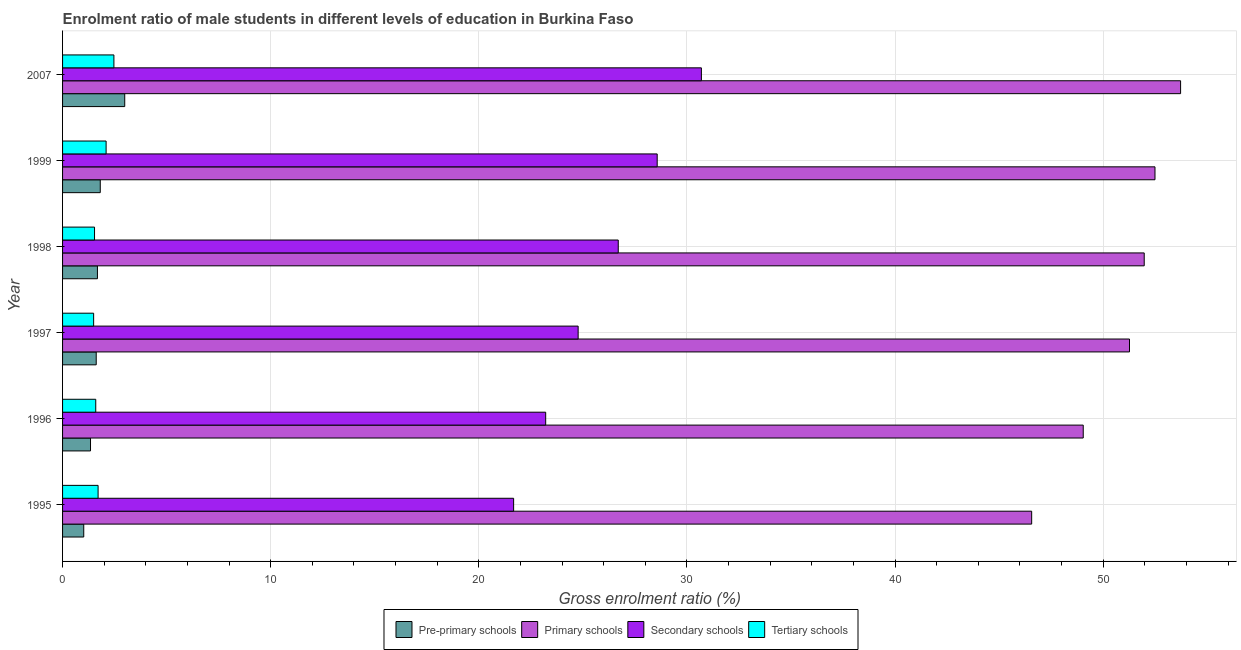Are the number of bars on each tick of the Y-axis equal?
Your answer should be very brief. Yes. How many bars are there on the 2nd tick from the top?
Provide a short and direct response. 4. In how many cases, is the number of bars for a given year not equal to the number of legend labels?
Offer a very short reply. 0. What is the gross enrolment ratio(female) in pre-primary schools in 1999?
Ensure brevity in your answer.  1.81. Across all years, what is the maximum gross enrolment ratio(female) in primary schools?
Offer a terse response. 53.72. Across all years, what is the minimum gross enrolment ratio(female) in pre-primary schools?
Provide a short and direct response. 1.02. What is the total gross enrolment ratio(female) in pre-primary schools in the graph?
Keep it short and to the point. 10.45. What is the difference between the gross enrolment ratio(female) in primary schools in 1998 and that in 1999?
Your answer should be compact. -0.52. What is the difference between the gross enrolment ratio(female) in pre-primary schools in 1997 and the gross enrolment ratio(female) in secondary schools in 1999?
Provide a succinct answer. -26.96. What is the average gross enrolment ratio(female) in secondary schools per year?
Your answer should be compact. 25.94. In the year 1995, what is the difference between the gross enrolment ratio(female) in secondary schools and gross enrolment ratio(female) in tertiary schools?
Provide a short and direct response. 19.97. In how many years, is the gross enrolment ratio(female) in pre-primary schools greater than 36 %?
Keep it short and to the point. 0. What is the ratio of the gross enrolment ratio(female) in secondary schools in 1995 to that in 2007?
Offer a very short reply. 0.71. Is the difference between the gross enrolment ratio(female) in primary schools in 1996 and 2007 greater than the difference between the gross enrolment ratio(female) in secondary schools in 1996 and 2007?
Your response must be concise. Yes. What is the difference between the highest and the second highest gross enrolment ratio(female) in tertiary schools?
Offer a very short reply. 0.37. What is the difference between the highest and the lowest gross enrolment ratio(female) in primary schools?
Provide a short and direct response. 7.16. Is the sum of the gross enrolment ratio(female) in secondary schools in 1996 and 1999 greater than the maximum gross enrolment ratio(female) in primary schools across all years?
Give a very brief answer. No. What does the 2nd bar from the top in 1995 represents?
Offer a very short reply. Secondary schools. What does the 2nd bar from the bottom in 1999 represents?
Make the answer very short. Primary schools. Is it the case that in every year, the sum of the gross enrolment ratio(female) in pre-primary schools and gross enrolment ratio(female) in primary schools is greater than the gross enrolment ratio(female) in secondary schools?
Your response must be concise. Yes. How many bars are there?
Make the answer very short. 24. Does the graph contain grids?
Make the answer very short. Yes. Where does the legend appear in the graph?
Give a very brief answer. Bottom center. What is the title of the graph?
Offer a very short reply. Enrolment ratio of male students in different levels of education in Burkina Faso. What is the Gross enrolment ratio (%) in Pre-primary schools in 1995?
Give a very brief answer. 1.02. What is the Gross enrolment ratio (%) in Primary schools in 1995?
Offer a terse response. 46.57. What is the Gross enrolment ratio (%) of Secondary schools in 1995?
Offer a terse response. 21.67. What is the Gross enrolment ratio (%) of Tertiary schools in 1995?
Give a very brief answer. 1.71. What is the Gross enrolment ratio (%) in Pre-primary schools in 1996?
Make the answer very short. 1.34. What is the Gross enrolment ratio (%) in Primary schools in 1996?
Keep it short and to the point. 49.04. What is the Gross enrolment ratio (%) of Secondary schools in 1996?
Provide a succinct answer. 23.21. What is the Gross enrolment ratio (%) in Tertiary schools in 1996?
Your answer should be compact. 1.59. What is the Gross enrolment ratio (%) of Pre-primary schools in 1997?
Keep it short and to the point. 1.62. What is the Gross enrolment ratio (%) in Primary schools in 1997?
Provide a short and direct response. 51.27. What is the Gross enrolment ratio (%) in Secondary schools in 1997?
Your response must be concise. 24.77. What is the Gross enrolment ratio (%) of Tertiary schools in 1997?
Your response must be concise. 1.49. What is the Gross enrolment ratio (%) in Pre-primary schools in 1998?
Offer a terse response. 1.68. What is the Gross enrolment ratio (%) of Primary schools in 1998?
Your answer should be compact. 51.97. What is the Gross enrolment ratio (%) of Secondary schools in 1998?
Make the answer very short. 26.7. What is the Gross enrolment ratio (%) of Tertiary schools in 1998?
Your answer should be very brief. 1.54. What is the Gross enrolment ratio (%) in Pre-primary schools in 1999?
Keep it short and to the point. 1.81. What is the Gross enrolment ratio (%) of Primary schools in 1999?
Your answer should be compact. 52.49. What is the Gross enrolment ratio (%) in Secondary schools in 1999?
Your answer should be very brief. 28.57. What is the Gross enrolment ratio (%) in Tertiary schools in 1999?
Make the answer very short. 2.09. What is the Gross enrolment ratio (%) of Pre-primary schools in 2007?
Make the answer very short. 2.99. What is the Gross enrolment ratio (%) in Primary schools in 2007?
Your answer should be very brief. 53.72. What is the Gross enrolment ratio (%) in Secondary schools in 2007?
Make the answer very short. 30.7. What is the Gross enrolment ratio (%) of Tertiary schools in 2007?
Keep it short and to the point. 2.47. Across all years, what is the maximum Gross enrolment ratio (%) in Pre-primary schools?
Your answer should be compact. 2.99. Across all years, what is the maximum Gross enrolment ratio (%) in Primary schools?
Provide a short and direct response. 53.72. Across all years, what is the maximum Gross enrolment ratio (%) of Secondary schools?
Make the answer very short. 30.7. Across all years, what is the maximum Gross enrolment ratio (%) of Tertiary schools?
Provide a short and direct response. 2.47. Across all years, what is the minimum Gross enrolment ratio (%) in Pre-primary schools?
Provide a short and direct response. 1.02. Across all years, what is the minimum Gross enrolment ratio (%) in Primary schools?
Your answer should be compact. 46.57. Across all years, what is the minimum Gross enrolment ratio (%) in Secondary schools?
Give a very brief answer. 21.67. Across all years, what is the minimum Gross enrolment ratio (%) of Tertiary schools?
Make the answer very short. 1.49. What is the total Gross enrolment ratio (%) in Pre-primary schools in the graph?
Offer a terse response. 10.45. What is the total Gross enrolment ratio (%) in Primary schools in the graph?
Ensure brevity in your answer.  305.06. What is the total Gross enrolment ratio (%) in Secondary schools in the graph?
Provide a short and direct response. 155.63. What is the total Gross enrolment ratio (%) in Tertiary schools in the graph?
Provide a succinct answer. 10.89. What is the difference between the Gross enrolment ratio (%) of Pre-primary schools in 1995 and that in 1996?
Your answer should be compact. -0.33. What is the difference between the Gross enrolment ratio (%) of Primary schools in 1995 and that in 1996?
Your response must be concise. -2.48. What is the difference between the Gross enrolment ratio (%) of Secondary schools in 1995 and that in 1996?
Give a very brief answer. -1.54. What is the difference between the Gross enrolment ratio (%) of Tertiary schools in 1995 and that in 1996?
Your answer should be compact. 0.11. What is the difference between the Gross enrolment ratio (%) of Pre-primary schools in 1995 and that in 1997?
Your answer should be compact. -0.6. What is the difference between the Gross enrolment ratio (%) of Primary schools in 1995 and that in 1997?
Offer a very short reply. -4.7. What is the difference between the Gross enrolment ratio (%) of Secondary schools in 1995 and that in 1997?
Provide a short and direct response. -3.1. What is the difference between the Gross enrolment ratio (%) in Tertiary schools in 1995 and that in 1997?
Offer a terse response. 0.21. What is the difference between the Gross enrolment ratio (%) of Pre-primary schools in 1995 and that in 1998?
Ensure brevity in your answer.  -0.66. What is the difference between the Gross enrolment ratio (%) in Primary schools in 1995 and that in 1998?
Offer a very short reply. -5.41. What is the difference between the Gross enrolment ratio (%) in Secondary schools in 1995 and that in 1998?
Provide a succinct answer. -5.03. What is the difference between the Gross enrolment ratio (%) in Tertiary schools in 1995 and that in 1998?
Give a very brief answer. 0.17. What is the difference between the Gross enrolment ratio (%) in Pre-primary schools in 1995 and that in 1999?
Provide a succinct answer. -0.79. What is the difference between the Gross enrolment ratio (%) in Primary schools in 1995 and that in 1999?
Give a very brief answer. -5.93. What is the difference between the Gross enrolment ratio (%) in Secondary schools in 1995 and that in 1999?
Your response must be concise. -6.9. What is the difference between the Gross enrolment ratio (%) of Tertiary schools in 1995 and that in 1999?
Provide a succinct answer. -0.39. What is the difference between the Gross enrolment ratio (%) of Pre-primary schools in 1995 and that in 2007?
Offer a terse response. -1.97. What is the difference between the Gross enrolment ratio (%) of Primary schools in 1995 and that in 2007?
Offer a very short reply. -7.16. What is the difference between the Gross enrolment ratio (%) of Secondary schools in 1995 and that in 2007?
Make the answer very short. -9.02. What is the difference between the Gross enrolment ratio (%) in Tertiary schools in 1995 and that in 2007?
Make the answer very short. -0.76. What is the difference between the Gross enrolment ratio (%) in Pre-primary schools in 1996 and that in 1997?
Give a very brief answer. -0.27. What is the difference between the Gross enrolment ratio (%) of Primary schools in 1996 and that in 1997?
Offer a very short reply. -2.22. What is the difference between the Gross enrolment ratio (%) in Secondary schools in 1996 and that in 1997?
Make the answer very short. -1.56. What is the difference between the Gross enrolment ratio (%) in Tertiary schools in 1996 and that in 1997?
Make the answer very short. 0.1. What is the difference between the Gross enrolment ratio (%) of Pre-primary schools in 1996 and that in 1998?
Offer a very short reply. -0.33. What is the difference between the Gross enrolment ratio (%) of Primary schools in 1996 and that in 1998?
Your answer should be very brief. -2.93. What is the difference between the Gross enrolment ratio (%) of Secondary schools in 1996 and that in 1998?
Keep it short and to the point. -3.49. What is the difference between the Gross enrolment ratio (%) in Tertiary schools in 1996 and that in 1998?
Offer a very short reply. 0.06. What is the difference between the Gross enrolment ratio (%) in Pre-primary schools in 1996 and that in 1999?
Keep it short and to the point. -0.47. What is the difference between the Gross enrolment ratio (%) in Primary schools in 1996 and that in 1999?
Your answer should be compact. -3.45. What is the difference between the Gross enrolment ratio (%) of Secondary schools in 1996 and that in 1999?
Offer a terse response. -5.36. What is the difference between the Gross enrolment ratio (%) in Tertiary schools in 1996 and that in 1999?
Provide a succinct answer. -0.5. What is the difference between the Gross enrolment ratio (%) of Pre-primary schools in 1996 and that in 2007?
Give a very brief answer. -1.64. What is the difference between the Gross enrolment ratio (%) in Primary schools in 1996 and that in 2007?
Your answer should be compact. -4.68. What is the difference between the Gross enrolment ratio (%) in Secondary schools in 1996 and that in 2007?
Provide a short and direct response. -7.48. What is the difference between the Gross enrolment ratio (%) in Tertiary schools in 1996 and that in 2007?
Keep it short and to the point. -0.87. What is the difference between the Gross enrolment ratio (%) in Pre-primary schools in 1997 and that in 1998?
Provide a short and direct response. -0.06. What is the difference between the Gross enrolment ratio (%) in Primary schools in 1997 and that in 1998?
Your response must be concise. -0.71. What is the difference between the Gross enrolment ratio (%) in Secondary schools in 1997 and that in 1998?
Provide a short and direct response. -1.93. What is the difference between the Gross enrolment ratio (%) of Tertiary schools in 1997 and that in 1998?
Your answer should be very brief. -0.04. What is the difference between the Gross enrolment ratio (%) in Pre-primary schools in 1997 and that in 1999?
Your response must be concise. -0.19. What is the difference between the Gross enrolment ratio (%) of Primary schools in 1997 and that in 1999?
Ensure brevity in your answer.  -1.22. What is the difference between the Gross enrolment ratio (%) in Secondary schools in 1997 and that in 1999?
Make the answer very short. -3.8. What is the difference between the Gross enrolment ratio (%) in Tertiary schools in 1997 and that in 1999?
Provide a succinct answer. -0.6. What is the difference between the Gross enrolment ratio (%) in Pre-primary schools in 1997 and that in 2007?
Offer a very short reply. -1.37. What is the difference between the Gross enrolment ratio (%) of Primary schools in 1997 and that in 2007?
Offer a very short reply. -2.45. What is the difference between the Gross enrolment ratio (%) of Secondary schools in 1997 and that in 2007?
Your answer should be very brief. -5.92. What is the difference between the Gross enrolment ratio (%) in Tertiary schools in 1997 and that in 2007?
Your response must be concise. -0.97. What is the difference between the Gross enrolment ratio (%) of Pre-primary schools in 1998 and that in 1999?
Keep it short and to the point. -0.14. What is the difference between the Gross enrolment ratio (%) in Primary schools in 1998 and that in 1999?
Your answer should be very brief. -0.52. What is the difference between the Gross enrolment ratio (%) of Secondary schools in 1998 and that in 1999?
Keep it short and to the point. -1.87. What is the difference between the Gross enrolment ratio (%) in Tertiary schools in 1998 and that in 1999?
Keep it short and to the point. -0.56. What is the difference between the Gross enrolment ratio (%) in Pre-primary schools in 1998 and that in 2007?
Provide a succinct answer. -1.31. What is the difference between the Gross enrolment ratio (%) of Primary schools in 1998 and that in 2007?
Offer a very short reply. -1.75. What is the difference between the Gross enrolment ratio (%) in Secondary schools in 1998 and that in 2007?
Ensure brevity in your answer.  -4. What is the difference between the Gross enrolment ratio (%) in Tertiary schools in 1998 and that in 2007?
Give a very brief answer. -0.93. What is the difference between the Gross enrolment ratio (%) of Pre-primary schools in 1999 and that in 2007?
Provide a short and direct response. -1.18. What is the difference between the Gross enrolment ratio (%) of Primary schools in 1999 and that in 2007?
Make the answer very short. -1.23. What is the difference between the Gross enrolment ratio (%) in Secondary schools in 1999 and that in 2007?
Provide a short and direct response. -2.12. What is the difference between the Gross enrolment ratio (%) in Tertiary schools in 1999 and that in 2007?
Make the answer very short. -0.37. What is the difference between the Gross enrolment ratio (%) in Pre-primary schools in 1995 and the Gross enrolment ratio (%) in Primary schools in 1996?
Your response must be concise. -48.03. What is the difference between the Gross enrolment ratio (%) in Pre-primary schools in 1995 and the Gross enrolment ratio (%) in Secondary schools in 1996?
Provide a succinct answer. -22.2. What is the difference between the Gross enrolment ratio (%) in Pre-primary schools in 1995 and the Gross enrolment ratio (%) in Tertiary schools in 1996?
Your answer should be compact. -0.58. What is the difference between the Gross enrolment ratio (%) in Primary schools in 1995 and the Gross enrolment ratio (%) in Secondary schools in 1996?
Provide a succinct answer. 23.35. What is the difference between the Gross enrolment ratio (%) of Primary schools in 1995 and the Gross enrolment ratio (%) of Tertiary schools in 1996?
Make the answer very short. 44.97. What is the difference between the Gross enrolment ratio (%) of Secondary schools in 1995 and the Gross enrolment ratio (%) of Tertiary schools in 1996?
Offer a terse response. 20.08. What is the difference between the Gross enrolment ratio (%) of Pre-primary schools in 1995 and the Gross enrolment ratio (%) of Primary schools in 1997?
Provide a succinct answer. -50.25. What is the difference between the Gross enrolment ratio (%) of Pre-primary schools in 1995 and the Gross enrolment ratio (%) of Secondary schools in 1997?
Your response must be concise. -23.76. What is the difference between the Gross enrolment ratio (%) in Pre-primary schools in 1995 and the Gross enrolment ratio (%) in Tertiary schools in 1997?
Make the answer very short. -0.47. What is the difference between the Gross enrolment ratio (%) in Primary schools in 1995 and the Gross enrolment ratio (%) in Secondary schools in 1997?
Your response must be concise. 21.79. What is the difference between the Gross enrolment ratio (%) of Primary schools in 1995 and the Gross enrolment ratio (%) of Tertiary schools in 1997?
Provide a succinct answer. 45.07. What is the difference between the Gross enrolment ratio (%) in Secondary schools in 1995 and the Gross enrolment ratio (%) in Tertiary schools in 1997?
Your answer should be very brief. 20.18. What is the difference between the Gross enrolment ratio (%) of Pre-primary schools in 1995 and the Gross enrolment ratio (%) of Primary schools in 1998?
Offer a very short reply. -50.96. What is the difference between the Gross enrolment ratio (%) of Pre-primary schools in 1995 and the Gross enrolment ratio (%) of Secondary schools in 1998?
Keep it short and to the point. -25.68. What is the difference between the Gross enrolment ratio (%) of Pre-primary schools in 1995 and the Gross enrolment ratio (%) of Tertiary schools in 1998?
Your answer should be very brief. -0.52. What is the difference between the Gross enrolment ratio (%) in Primary schools in 1995 and the Gross enrolment ratio (%) in Secondary schools in 1998?
Your answer should be very brief. 19.87. What is the difference between the Gross enrolment ratio (%) of Primary schools in 1995 and the Gross enrolment ratio (%) of Tertiary schools in 1998?
Provide a short and direct response. 45.03. What is the difference between the Gross enrolment ratio (%) of Secondary schools in 1995 and the Gross enrolment ratio (%) of Tertiary schools in 1998?
Make the answer very short. 20.14. What is the difference between the Gross enrolment ratio (%) in Pre-primary schools in 1995 and the Gross enrolment ratio (%) in Primary schools in 1999?
Give a very brief answer. -51.47. What is the difference between the Gross enrolment ratio (%) of Pre-primary schools in 1995 and the Gross enrolment ratio (%) of Secondary schools in 1999?
Give a very brief answer. -27.55. What is the difference between the Gross enrolment ratio (%) in Pre-primary schools in 1995 and the Gross enrolment ratio (%) in Tertiary schools in 1999?
Provide a succinct answer. -1.07. What is the difference between the Gross enrolment ratio (%) in Primary schools in 1995 and the Gross enrolment ratio (%) in Secondary schools in 1999?
Keep it short and to the point. 17.99. What is the difference between the Gross enrolment ratio (%) in Primary schools in 1995 and the Gross enrolment ratio (%) in Tertiary schools in 1999?
Keep it short and to the point. 44.47. What is the difference between the Gross enrolment ratio (%) in Secondary schools in 1995 and the Gross enrolment ratio (%) in Tertiary schools in 1999?
Keep it short and to the point. 19.58. What is the difference between the Gross enrolment ratio (%) of Pre-primary schools in 1995 and the Gross enrolment ratio (%) of Primary schools in 2007?
Keep it short and to the point. -52.7. What is the difference between the Gross enrolment ratio (%) of Pre-primary schools in 1995 and the Gross enrolment ratio (%) of Secondary schools in 2007?
Your answer should be compact. -29.68. What is the difference between the Gross enrolment ratio (%) of Pre-primary schools in 1995 and the Gross enrolment ratio (%) of Tertiary schools in 2007?
Ensure brevity in your answer.  -1.45. What is the difference between the Gross enrolment ratio (%) of Primary schools in 1995 and the Gross enrolment ratio (%) of Secondary schools in 2007?
Make the answer very short. 15.87. What is the difference between the Gross enrolment ratio (%) in Primary schools in 1995 and the Gross enrolment ratio (%) in Tertiary schools in 2007?
Your answer should be compact. 44.1. What is the difference between the Gross enrolment ratio (%) in Secondary schools in 1995 and the Gross enrolment ratio (%) in Tertiary schools in 2007?
Offer a terse response. 19.21. What is the difference between the Gross enrolment ratio (%) in Pre-primary schools in 1996 and the Gross enrolment ratio (%) in Primary schools in 1997?
Provide a short and direct response. -49.92. What is the difference between the Gross enrolment ratio (%) of Pre-primary schools in 1996 and the Gross enrolment ratio (%) of Secondary schools in 1997?
Ensure brevity in your answer.  -23.43. What is the difference between the Gross enrolment ratio (%) of Pre-primary schools in 1996 and the Gross enrolment ratio (%) of Tertiary schools in 1997?
Your answer should be very brief. -0.15. What is the difference between the Gross enrolment ratio (%) of Primary schools in 1996 and the Gross enrolment ratio (%) of Secondary schools in 1997?
Provide a short and direct response. 24.27. What is the difference between the Gross enrolment ratio (%) in Primary schools in 1996 and the Gross enrolment ratio (%) in Tertiary schools in 1997?
Your response must be concise. 47.55. What is the difference between the Gross enrolment ratio (%) in Secondary schools in 1996 and the Gross enrolment ratio (%) in Tertiary schools in 1997?
Give a very brief answer. 21.72. What is the difference between the Gross enrolment ratio (%) of Pre-primary schools in 1996 and the Gross enrolment ratio (%) of Primary schools in 1998?
Make the answer very short. -50.63. What is the difference between the Gross enrolment ratio (%) in Pre-primary schools in 1996 and the Gross enrolment ratio (%) in Secondary schools in 1998?
Ensure brevity in your answer.  -25.36. What is the difference between the Gross enrolment ratio (%) in Pre-primary schools in 1996 and the Gross enrolment ratio (%) in Tertiary schools in 1998?
Your response must be concise. -0.19. What is the difference between the Gross enrolment ratio (%) of Primary schools in 1996 and the Gross enrolment ratio (%) of Secondary schools in 1998?
Give a very brief answer. 22.34. What is the difference between the Gross enrolment ratio (%) of Primary schools in 1996 and the Gross enrolment ratio (%) of Tertiary schools in 1998?
Provide a short and direct response. 47.51. What is the difference between the Gross enrolment ratio (%) of Secondary schools in 1996 and the Gross enrolment ratio (%) of Tertiary schools in 1998?
Your response must be concise. 21.68. What is the difference between the Gross enrolment ratio (%) of Pre-primary schools in 1996 and the Gross enrolment ratio (%) of Primary schools in 1999?
Keep it short and to the point. -51.15. What is the difference between the Gross enrolment ratio (%) of Pre-primary schools in 1996 and the Gross enrolment ratio (%) of Secondary schools in 1999?
Your response must be concise. -27.23. What is the difference between the Gross enrolment ratio (%) in Pre-primary schools in 1996 and the Gross enrolment ratio (%) in Tertiary schools in 1999?
Make the answer very short. -0.75. What is the difference between the Gross enrolment ratio (%) in Primary schools in 1996 and the Gross enrolment ratio (%) in Secondary schools in 1999?
Your response must be concise. 20.47. What is the difference between the Gross enrolment ratio (%) of Primary schools in 1996 and the Gross enrolment ratio (%) of Tertiary schools in 1999?
Make the answer very short. 46.95. What is the difference between the Gross enrolment ratio (%) of Secondary schools in 1996 and the Gross enrolment ratio (%) of Tertiary schools in 1999?
Give a very brief answer. 21.12. What is the difference between the Gross enrolment ratio (%) of Pre-primary schools in 1996 and the Gross enrolment ratio (%) of Primary schools in 2007?
Ensure brevity in your answer.  -52.38. What is the difference between the Gross enrolment ratio (%) of Pre-primary schools in 1996 and the Gross enrolment ratio (%) of Secondary schools in 2007?
Your answer should be compact. -29.35. What is the difference between the Gross enrolment ratio (%) of Pre-primary schools in 1996 and the Gross enrolment ratio (%) of Tertiary schools in 2007?
Offer a terse response. -1.12. What is the difference between the Gross enrolment ratio (%) of Primary schools in 1996 and the Gross enrolment ratio (%) of Secondary schools in 2007?
Offer a terse response. 18.35. What is the difference between the Gross enrolment ratio (%) of Primary schools in 1996 and the Gross enrolment ratio (%) of Tertiary schools in 2007?
Your answer should be very brief. 46.58. What is the difference between the Gross enrolment ratio (%) in Secondary schools in 1996 and the Gross enrolment ratio (%) in Tertiary schools in 2007?
Give a very brief answer. 20.75. What is the difference between the Gross enrolment ratio (%) of Pre-primary schools in 1997 and the Gross enrolment ratio (%) of Primary schools in 1998?
Provide a short and direct response. -50.36. What is the difference between the Gross enrolment ratio (%) of Pre-primary schools in 1997 and the Gross enrolment ratio (%) of Secondary schools in 1998?
Your response must be concise. -25.08. What is the difference between the Gross enrolment ratio (%) of Pre-primary schools in 1997 and the Gross enrolment ratio (%) of Tertiary schools in 1998?
Your answer should be compact. 0.08. What is the difference between the Gross enrolment ratio (%) of Primary schools in 1997 and the Gross enrolment ratio (%) of Secondary schools in 1998?
Your answer should be compact. 24.57. What is the difference between the Gross enrolment ratio (%) in Primary schools in 1997 and the Gross enrolment ratio (%) in Tertiary schools in 1998?
Offer a terse response. 49.73. What is the difference between the Gross enrolment ratio (%) in Secondary schools in 1997 and the Gross enrolment ratio (%) in Tertiary schools in 1998?
Make the answer very short. 23.24. What is the difference between the Gross enrolment ratio (%) in Pre-primary schools in 1997 and the Gross enrolment ratio (%) in Primary schools in 1999?
Keep it short and to the point. -50.87. What is the difference between the Gross enrolment ratio (%) in Pre-primary schools in 1997 and the Gross enrolment ratio (%) in Secondary schools in 1999?
Provide a succinct answer. -26.96. What is the difference between the Gross enrolment ratio (%) in Pre-primary schools in 1997 and the Gross enrolment ratio (%) in Tertiary schools in 1999?
Your response must be concise. -0.48. What is the difference between the Gross enrolment ratio (%) of Primary schools in 1997 and the Gross enrolment ratio (%) of Secondary schools in 1999?
Ensure brevity in your answer.  22.69. What is the difference between the Gross enrolment ratio (%) of Primary schools in 1997 and the Gross enrolment ratio (%) of Tertiary schools in 1999?
Offer a terse response. 49.17. What is the difference between the Gross enrolment ratio (%) of Secondary schools in 1997 and the Gross enrolment ratio (%) of Tertiary schools in 1999?
Make the answer very short. 22.68. What is the difference between the Gross enrolment ratio (%) of Pre-primary schools in 1997 and the Gross enrolment ratio (%) of Primary schools in 2007?
Your answer should be very brief. -52.1. What is the difference between the Gross enrolment ratio (%) in Pre-primary schools in 1997 and the Gross enrolment ratio (%) in Secondary schools in 2007?
Your answer should be compact. -29.08. What is the difference between the Gross enrolment ratio (%) in Pre-primary schools in 1997 and the Gross enrolment ratio (%) in Tertiary schools in 2007?
Ensure brevity in your answer.  -0.85. What is the difference between the Gross enrolment ratio (%) of Primary schools in 1997 and the Gross enrolment ratio (%) of Secondary schools in 2007?
Your answer should be compact. 20.57. What is the difference between the Gross enrolment ratio (%) of Primary schools in 1997 and the Gross enrolment ratio (%) of Tertiary schools in 2007?
Ensure brevity in your answer.  48.8. What is the difference between the Gross enrolment ratio (%) of Secondary schools in 1997 and the Gross enrolment ratio (%) of Tertiary schools in 2007?
Your answer should be compact. 22.31. What is the difference between the Gross enrolment ratio (%) of Pre-primary schools in 1998 and the Gross enrolment ratio (%) of Primary schools in 1999?
Provide a succinct answer. -50.82. What is the difference between the Gross enrolment ratio (%) of Pre-primary schools in 1998 and the Gross enrolment ratio (%) of Secondary schools in 1999?
Offer a terse response. -26.9. What is the difference between the Gross enrolment ratio (%) in Pre-primary schools in 1998 and the Gross enrolment ratio (%) in Tertiary schools in 1999?
Your answer should be very brief. -0.42. What is the difference between the Gross enrolment ratio (%) in Primary schools in 1998 and the Gross enrolment ratio (%) in Secondary schools in 1999?
Keep it short and to the point. 23.4. What is the difference between the Gross enrolment ratio (%) of Primary schools in 1998 and the Gross enrolment ratio (%) of Tertiary schools in 1999?
Provide a succinct answer. 49.88. What is the difference between the Gross enrolment ratio (%) in Secondary schools in 1998 and the Gross enrolment ratio (%) in Tertiary schools in 1999?
Keep it short and to the point. 24.61. What is the difference between the Gross enrolment ratio (%) of Pre-primary schools in 1998 and the Gross enrolment ratio (%) of Primary schools in 2007?
Make the answer very short. -52.05. What is the difference between the Gross enrolment ratio (%) in Pre-primary schools in 1998 and the Gross enrolment ratio (%) in Secondary schools in 2007?
Ensure brevity in your answer.  -29.02. What is the difference between the Gross enrolment ratio (%) of Pre-primary schools in 1998 and the Gross enrolment ratio (%) of Tertiary schools in 2007?
Provide a short and direct response. -0.79. What is the difference between the Gross enrolment ratio (%) in Primary schools in 1998 and the Gross enrolment ratio (%) in Secondary schools in 2007?
Give a very brief answer. 21.28. What is the difference between the Gross enrolment ratio (%) in Primary schools in 1998 and the Gross enrolment ratio (%) in Tertiary schools in 2007?
Offer a terse response. 49.51. What is the difference between the Gross enrolment ratio (%) of Secondary schools in 1998 and the Gross enrolment ratio (%) of Tertiary schools in 2007?
Keep it short and to the point. 24.23. What is the difference between the Gross enrolment ratio (%) in Pre-primary schools in 1999 and the Gross enrolment ratio (%) in Primary schools in 2007?
Your answer should be compact. -51.91. What is the difference between the Gross enrolment ratio (%) of Pre-primary schools in 1999 and the Gross enrolment ratio (%) of Secondary schools in 2007?
Offer a terse response. -28.88. What is the difference between the Gross enrolment ratio (%) of Pre-primary schools in 1999 and the Gross enrolment ratio (%) of Tertiary schools in 2007?
Make the answer very short. -0.66. What is the difference between the Gross enrolment ratio (%) of Primary schools in 1999 and the Gross enrolment ratio (%) of Secondary schools in 2007?
Give a very brief answer. 21.8. What is the difference between the Gross enrolment ratio (%) in Primary schools in 1999 and the Gross enrolment ratio (%) in Tertiary schools in 2007?
Keep it short and to the point. 50.02. What is the difference between the Gross enrolment ratio (%) in Secondary schools in 1999 and the Gross enrolment ratio (%) in Tertiary schools in 2007?
Offer a very short reply. 26.11. What is the average Gross enrolment ratio (%) of Pre-primary schools per year?
Offer a terse response. 1.74. What is the average Gross enrolment ratio (%) of Primary schools per year?
Offer a very short reply. 50.84. What is the average Gross enrolment ratio (%) of Secondary schools per year?
Offer a terse response. 25.94. What is the average Gross enrolment ratio (%) of Tertiary schools per year?
Your answer should be very brief. 1.81. In the year 1995, what is the difference between the Gross enrolment ratio (%) in Pre-primary schools and Gross enrolment ratio (%) in Primary schools?
Give a very brief answer. -45.55. In the year 1995, what is the difference between the Gross enrolment ratio (%) in Pre-primary schools and Gross enrolment ratio (%) in Secondary schools?
Provide a short and direct response. -20.66. In the year 1995, what is the difference between the Gross enrolment ratio (%) of Pre-primary schools and Gross enrolment ratio (%) of Tertiary schools?
Make the answer very short. -0.69. In the year 1995, what is the difference between the Gross enrolment ratio (%) of Primary schools and Gross enrolment ratio (%) of Secondary schools?
Make the answer very short. 24.89. In the year 1995, what is the difference between the Gross enrolment ratio (%) in Primary schools and Gross enrolment ratio (%) in Tertiary schools?
Ensure brevity in your answer.  44.86. In the year 1995, what is the difference between the Gross enrolment ratio (%) of Secondary schools and Gross enrolment ratio (%) of Tertiary schools?
Your answer should be very brief. 19.97. In the year 1996, what is the difference between the Gross enrolment ratio (%) of Pre-primary schools and Gross enrolment ratio (%) of Primary schools?
Provide a short and direct response. -47.7. In the year 1996, what is the difference between the Gross enrolment ratio (%) in Pre-primary schools and Gross enrolment ratio (%) in Secondary schools?
Keep it short and to the point. -21.87. In the year 1996, what is the difference between the Gross enrolment ratio (%) in Pre-primary schools and Gross enrolment ratio (%) in Tertiary schools?
Ensure brevity in your answer.  -0.25. In the year 1996, what is the difference between the Gross enrolment ratio (%) in Primary schools and Gross enrolment ratio (%) in Secondary schools?
Make the answer very short. 25.83. In the year 1996, what is the difference between the Gross enrolment ratio (%) in Primary schools and Gross enrolment ratio (%) in Tertiary schools?
Ensure brevity in your answer.  47.45. In the year 1996, what is the difference between the Gross enrolment ratio (%) in Secondary schools and Gross enrolment ratio (%) in Tertiary schools?
Provide a short and direct response. 21.62. In the year 1997, what is the difference between the Gross enrolment ratio (%) of Pre-primary schools and Gross enrolment ratio (%) of Primary schools?
Ensure brevity in your answer.  -49.65. In the year 1997, what is the difference between the Gross enrolment ratio (%) of Pre-primary schools and Gross enrolment ratio (%) of Secondary schools?
Provide a succinct answer. -23.16. In the year 1997, what is the difference between the Gross enrolment ratio (%) in Pre-primary schools and Gross enrolment ratio (%) in Tertiary schools?
Make the answer very short. 0.12. In the year 1997, what is the difference between the Gross enrolment ratio (%) of Primary schools and Gross enrolment ratio (%) of Secondary schools?
Offer a very short reply. 26.49. In the year 1997, what is the difference between the Gross enrolment ratio (%) of Primary schools and Gross enrolment ratio (%) of Tertiary schools?
Provide a succinct answer. 49.77. In the year 1997, what is the difference between the Gross enrolment ratio (%) in Secondary schools and Gross enrolment ratio (%) in Tertiary schools?
Your answer should be very brief. 23.28. In the year 1998, what is the difference between the Gross enrolment ratio (%) in Pre-primary schools and Gross enrolment ratio (%) in Primary schools?
Your response must be concise. -50.3. In the year 1998, what is the difference between the Gross enrolment ratio (%) of Pre-primary schools and Gross enrolment ratio (%) of Secondary schools?
Your answer should be compact. -25.02. In the year 1998, what is the difference between the Gross enrolment ratio (%) in Pre-primary schools and Gross enrolment ratio (%) in Tertiary schools?
Offer a terse response. 0.14. In the year 1998, what is the difference between the Gross enrolment ratio (%) of Primary schools and Gross enrolment ratio (%) of Secondary schools?
Ensure brevity in your answer.  25.27. In the year 1998, what is the difference between the Gross enrolment ratio (%) of Primary schools and Gross enrolment ratio (%) of Tertiary schools?
Your response must be concise. 50.44. In the year 1998, what is the difference between the Gross enrolment ratio (%) of Secondary schools and Gross enrolment ratio (%) of Tertiary schools?
Give a very brief answer. 25.16. In the year 1999, what is the difference between the Gross enrolment ratio (%) of Pre-primary schools and Gross enrolment ratio (%) of Primary schools?
Ensure brevity in your answer.  -50.68. In the year 1999, what is the difference between the Gross enrolment ratio (%) of Pre-primary schools and Gross enrolment ratio (%) of Secondary schools?
Offer a terse response. -26.76. In the year 1999, what is the difference between the Gross enrolment ratio (%) of Pre-primary schools and Gross enrolment ratio (%) of Tertiary schools?
Provide a succinct answer. -0.28. In the year 1999, what is the difference between the Gross enrolment ratio (%) of Primary schools and Gross enrolment ratio (%) of Secondary schools?
Your answer should be very brief. 23.92. In the year 1999, what is the difference between the Gross enrolment ratio (%) of Primary schools and Gross enrolment ratio (%) of Tertiary schools?
Offer a very short reply. 50.4. In the year 1999, what is the difference between the Gross enrolment ratio (%) in Secondary schools and Gross enrolment ratio (%) in Tertiary schools?
Make the answer very short. 26.48. In the year 2007, what is the difference between the Gross enrolment ratio (%) in Pre-primary schools and Gross enrolment ratio (%) in Primary schools?
Give a very brief answer. -50.73. In the year 2007, what is the difference between the Gross enrolment ratio (%) of Pre-primary schools and Gross enrolment ratio (%) of Secondary schools?
Keep it short and to the point. -27.71. In the year 2007, what is the difference between the Gross enrolment ratio (%) of Pre-primary schools and Gross enrolment ratio (%) of Tertiary schools?
Keep it short and to the point. 0.52. In the year 2007, what is the difference between the Gross enrolment ratio (%) of Primary schools and Gross enrolment ratio (%) of Secondary schools?
Ensure brevity in your answer.  23.03. In the year 2007, what is the difference between the Gross enrolment ratio (%) of Primary schools and Gross enrolment ratio (%) of Tertiary schools?
Provide a succinct answer. 51.25. In the year 2007, what is the difference between the Gross enrolment ratio (%) in Secondary schools and Gross enrolment ratio (%) in Tertiary schools?
Offer a very short reply. 28.23. What is the ratio of the Gross enrolment ratio (%) of Pre-primary schools in 1995 to that in 1996?
Make the answer very short. 0.76. What is the ratio of the Gross enrolment ratio (%) of Primary schools in 1995 to that in 1996?
Make the answer very short. 0.95. What is the ratio of the Gross enrolment ratio (%) in Secondary schools in 1995 to that in 1996?
Keep it short and to the point. 0.93. What is the ratio of the Gross enrolment ratio (%) in Tertiary schools in 1995 to that in 1996?
Ensure brevity in your answer.  1.07. What is the ratio of the Gross enrolment ratio (%) of Pre-primary schools in 1995 to that in 1997?
Make the answer very short. 0.63. What is the ratio of the Gross enrolment ratio (%) in Primary schools in 1995 to that in 1997?
Your answer should be very brief. 0.91. What is the ratio of the Gross enrolment ratio (%) of Secondary schools in 1995 to that in 1997?
Offer a terse response. 0.87. What is the ratio of the Gross enrolment ratio (%) in Tertiary schools in 1995 to that in 1997?
Give a very brief answer. 1.14. What is the ratio of the Gross enrolment ratio (%) of Pre-primary schools in 1995 to that in 1998?
Your response must be concise. 0.61. What is the ratio of the Gross enrolment ratio (%) of Primary schools in 1995 to that in 1998?
Keep it short and to the point. 0.9. What is the ratio of the Gross enrolment ratio (%) of Secondary schools in 1995 to that in 1998?
Give a very brief answer. 0.81. What is the ratio of the Gross enrolment ratio (%) in Tertiary schools in 1995 to that in 1998?
Provide a short and direct response. 1.11. What is the ratio of the Gross enrolment ratio (%) of Pre-primary schools in 1995 to that in 1999?
Offer a very short reply. 0.56. What is the ratio of the Gross enrolment ratio (%) in Primary schools in 1995 to that in 1999?
Keep it short and to the point. 0.89. What is the ratio of the Gross enrolment ratio (%) of Secondary schools in 1995 to that in 1999?
Keep it short and to the point. 0.76. What is the ratio of the Gross enrolment ratio (%) of Tertiary schools in 1995 to that in 1999?
Your answer should be very brief. 0.82. What is the ratio of the Gross enrolment ratio (%) in Pre-primary schools in 1995 to that in 2007?
Offer a very short reply. 0.34. What is the ratio of the Gross enrolment ratio (%) of Primary schools in 1995 to that in 2007?
Offer a terse response. 0.87. What is the ratio of the Gross enrolment ratio (%) in Secondary schools in 1995 to that in 2007?
Make the answer very short. 0.71. What is the ratio of the Gross enrolment ratio (%) of Tertiary schools in 1995 to that in 2007?
Offer a terse response. 0.69. What is the ratio of the Gross enrolment ratio (%) in Pre-primary schools in 1996 to that in 1997?
Ensure brevity in your answer.  0.83. What is the ratio of the Gross enrolment ratio (%) of Primary schools in 1996 to that in 1997?
Offer a very short reply. 0.96. What is the ratio of the Gross enrolment ratio (%) of Secondary schools in 1996 to that in 1997?
Make the answer very short. 0.94. What is the ratio of the Gross enrolment ratio (%) in Tertiary schools in 1996 to that in 1997?
Provide a short and direct response. 1.07. What is the ratio of the Gross enrolment ratio (%) of Pre-primary schools in 1996 to that in 1998?
Your response must be concise. 0.8. What is the ratio of the Gross enrolment ratio (%) in Primary schools in 1996 to that in 1998?
Your answer should be compact. 0.94. What is the ratio of the Gross enrolment ratio (%) in Secondary schools in 1996 to that in 1998?
Keep it short and to the point. 0.87. What is the ratio of the Gross enrolment ratio (%) in Tertiary schools in 1996 to that in 1998?
Offer a terse response. 1.04. What is the ratio of the Gross enrolment ratio (%) of Pre-primary schools in 1996 to that in 1999?
Your answer should be very brief. 0.74. What is the ratio of the Gross enrolment ratio (%) in Primary schools in 1996 to that in 1999?
Keep it short and to the point. 0.93. What is the ratio of the Gross enrolment ratio (%) in Secondary schools in 1996 to that in 1999?
Give a very brief answer. 0.81. What is the ratio of the Gross enrolment ratio (%) in Tertiary schools in 1996 to that in 1999?
Ensure brevity in your answer.  0.76. What is the ratio of the Gross enrolment ratio (%) of Pre-primary schools in 1996 to that in 2007?
Give a very brief answer. 0.45. What is the ratio of the Gross enrolment ratio (%) of Primary schools in 1996 to that in 2007?
Your response must be concise. 0.91. What is the ratio of the Gross enrolment ratio (%) in Secondary schools in 1996 to that in 2007?
Provide a succinct answer. 0.76. What is the ratio of the Gross enrolment ratio (%) of Tertiary schools in 1996 to that in 2007?
Your answer should be compact. 0.65. What is the ratio of the Gross enrolment ratio (%) in Pre-primary schools in 1997 to that in 1998?
Ensure brevity in your answer.  0.96. What is the ratio of the Gross enrolment ratio (%) of Primary schools in 1997 to that in 1998?
Your response must be concise. 0.99. What is the ratio of the Gross enrolment ratio (%) of Secondary schools in 1997 to that in 1998?
Offer a very short reply. 0.93. What is the ratio of the Gross enrolment ratio (%) in Tertiary schools in 1997 to that in 1998?
Your answer should be compact. 0.97. What is the ratio of the Gross enrolment ratio (%) in Pre-primary schools in 1997 to that in 1999?
Make the answer very short. 0.89. What is the ratio of the Gross enrolment ratio (%) in Primary schools in 1997 to that in 1999?
Your response must be concise. 0.98. What is the ratio of the Gross enrolment ratio (%) of Secondary schools in 1997 to that in 1999?
Keep it short and to the point. 0.87. What is the ratio of the Gross enrolment ratio (%) in Tertiary schools in 1997 to that in 1999?
Ensure brevity in your answer.  0.71. What is the ratio of the Gross enrolment ratio (%) in Pre-primary schools in 1997 to that in 2007?
Keep it short and to the point. 0.54. What is the ratio of the Gross enrolment ratio (%) of Primary schools in 1997 to that in 2007?
Make the answer very short. 0.95. What is the ratio of the Gross enrolment ratio (%) in Secondary schools in 1997 to that in 2007?
Keep it short and to the point. 0.81. What is the ratio of the Gross enrolment ratio (%) in Tertiary schools in 1997 to that in 2007?
Keep it short and to the point. 0.61. What is the ratio of the Gross enrolment ratio (%) in Pre-primary schools in 1998 to that in 1999?
Make the answer very short. 0.93. What is the ratio of the Gross enrolment ratio (%) of Primary schools in 1998 to that in 1999?
Offer a very short reply. 0.99. What is the ratio of the Gross enrolment ratio (%) in Secondary schools in 1998 to that in 1999?
Give a very brief answer. 0.93. What is the ratio of the Gross enrolment ratio (%) in Tertiary schools in 1998 to that in 1999?
Provide a succinct answer. 0.73. What is the ratio of the Gross enrolment ratio (%) of Pre-primary schools in 1998 to that in 2007?
Offer a very short reply. 0.56. What is the ratio of the Gross enrolment ratio (%) of Primary schools in 1998 to that in 2007?
Make the answer very short. 0.97. What is the ratio of the Gross enrolment ratio (%) in Secondary schools in 1998 to that in 2007?
Give a very brief answer. 0.87. What is the ratio of the Gross enrolment ratio (%) of Tertiary schools in 1998 to that in 2007?
Give a very brief answer. 0.62. What is the ratio of the Gross enrolment ratio (%) in Pre-primary schools in 1999 to that in 2007?
Provide a succinct answer. 0.61. What is the ratio of the Gross enrolment ratio (%) in Primary schools in 1999 to that in 2007?
Your response must be concise. 0.98. What is the ratio of the Gross enrolment ratio (%) of Secondary schools in 1999 to that in 2007?
Offer a very short reply. 0.93. What is the ratio of the Gross enrolment ratio (%) in Tertiary schools in 1999 to that in 2007?
Your answer should be very brief. 0.85. What is the difference between the highest and the second highest Gross enrolment ratio (%) of Pre-primary schools?
Your answer should be compact. 1.18. What is the difference between the highest and the second highest Gross enrolment ratio (%) in Primary schools?
Your answer should be compact. 1.23. What is the difference between the highest and the second highest Gross enrolment ratio (%) in Secondary schools?
Keep it short and to the point. 2.12. What is the difference between the highest and the second highest Gross enrolment ratio (%) in Tertiary schools?
Make the answer very short. 0.37. What is the difference between the highest and the lowest Gross enrolment ratio (%) in Pre-primary schools?
Ensure brevity in your answer.  1.97. What is the difference between the highest and the lowest Gross enrolment ratio (%) in Primary schools?
Your answer should be very brief. 7.16. What is the difference between the highest and the lowest Gross enrolment ratio (%) in Secondary schools?
Make the answer very short. 9.02. What is the difference between the highest and the lowest Gross enrolment ratio (%) of Tertiary schools?
Ensure brevity in your answer.  0.97. 